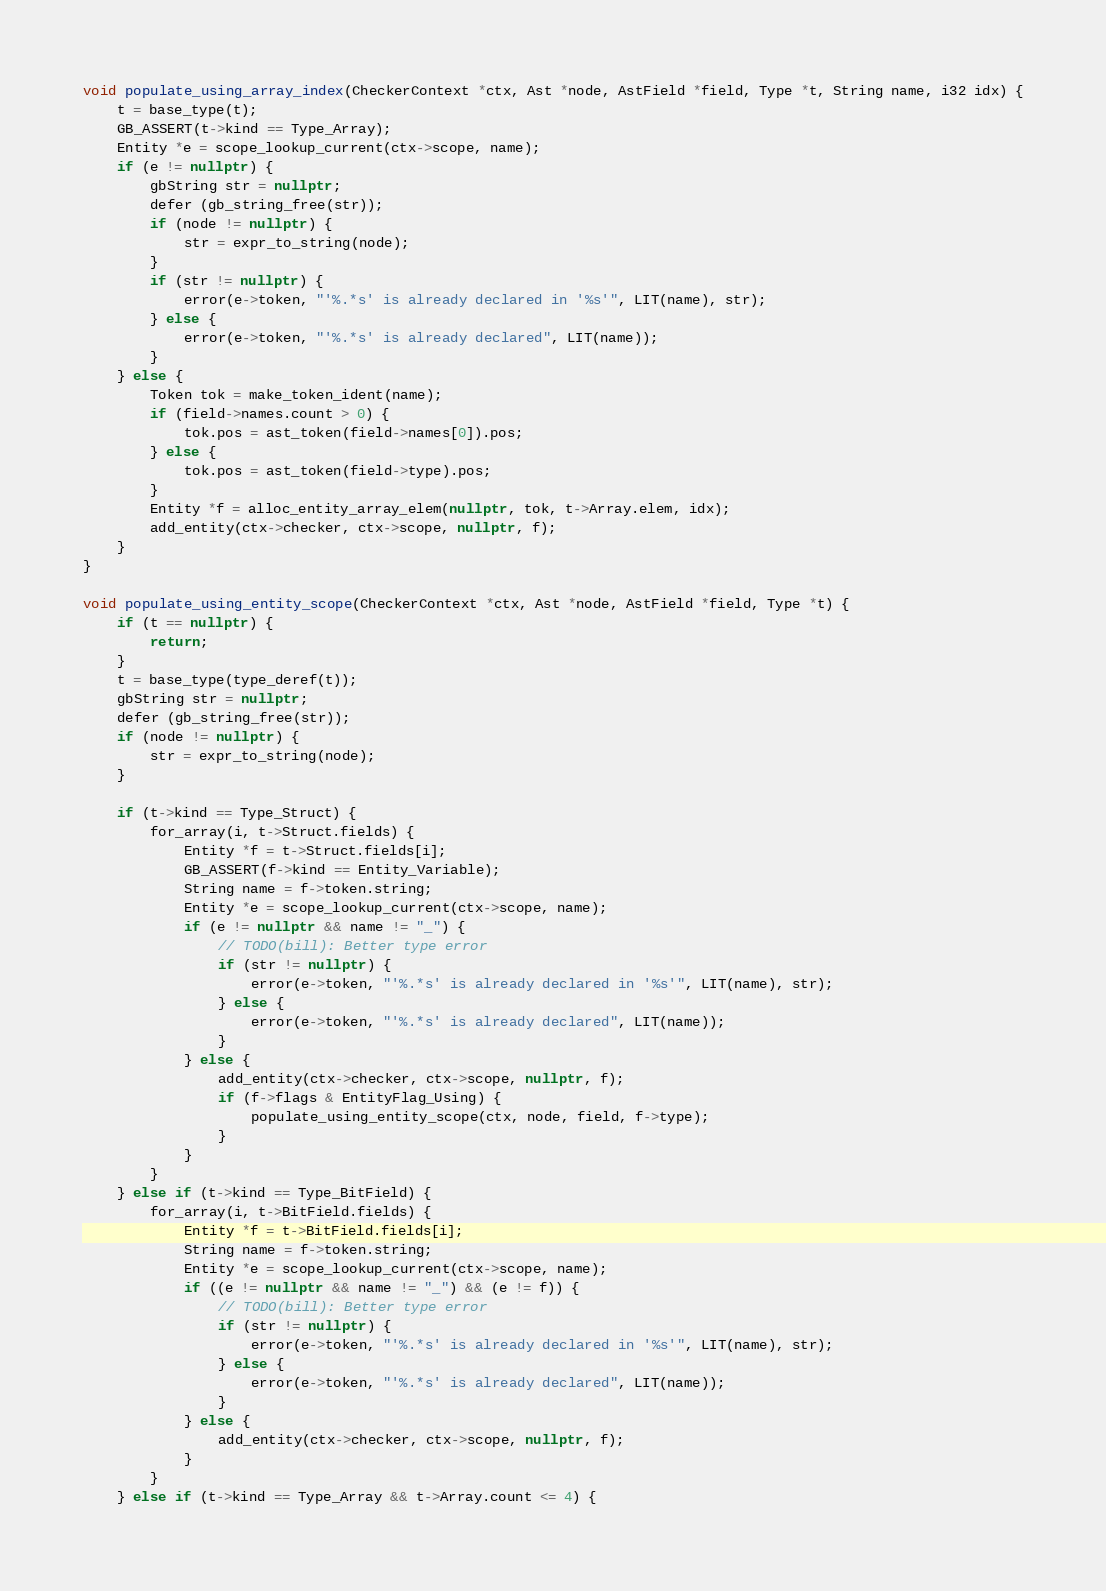Convert code to text. <code><loc_0><loc_0><loc_500><loc_500><_C++_>
void populate_using_array_index(CheckerContext *ctx, Ast *node, AstField *field, Type *t, String name, i32 idx) {
	t = base_type(t);
	GB_ASSERT(t->kind == Type_Array);
	Entity *e = scope_lookup_current(ctx->scope, name);
	if (e != nullptr) {
		gbString str = nullptr;
		defer (gb_string_free(str));
		if (node != nullptr) {
			str = expr_to_string(node);
		}
		if (str != nullptr) {
			error(e->token, "'%.*s' is already declared in '%s'", LIT(name), str);
		} else {
			error(e->token, "'%.*s' is already declared", LIT(name));
		}
	} else {
		Token tok = make_token_ident(name);
		if (field->names.count > 0) {
			tok.pos = ast_token(field->names[0]).pos;
		} else {
			tok.pos = ast_token(field->type).pos;
		}
		Entity *f = alloc_entity_array_elem(nullptr, tok, t->Array.elem, idx);
		add_entity(ctx->checker, ctx->scope, nullptr, f);
	}
}

void populate_using_entity_scope(CheckerContext *ctx, Ast *node, AstField *field, Type *t) {
	if (t == nullptr) {
		return;
	}
	t = base_type(type_deref(t));
	gbString str = nullptr;
	defer (gb_string_free(str));
	if (node != nullptr) {
		str = expr_to_string(node);
	}

	if (t->kind == Type_Struct) {
		for_array(i, t->Struct.fields) {
			Entity *f = t->Struct.fields[i];
			GB_ASSERT(f->kind == Entity_Variable);
			String name = f->token.string;
			Entity *e = scope_lookup_current(ctx->scope, name);
			if (e != nullptr && name != "_") {
				// TODO(bill): Better type error
				if (str != nullptr) {
					error(e->token, "'%.*s' is already declared in '%s'", LIT(name), str);
				} else {
					error(e->token, "'%.*s' is already declared", LIT(name));
				}
			} else {
				add_entity(ctx->checker, ctx->scope, nullptr, f);
				if (f->flags & EntityFlag_Using) {
					populate_using_entity_scope(ctx, node, field, f->type);
				}
			}
		}
	} else if (t->kind == Type_BitField) {
		for_array(i, t->BitField.fields) {
			Entity *f = t->BitField.fields[i];
			String name = f->token.string;
			Entity *e = scope_lookup_current(ctx->scope, name);
			if ((e != nullptr && name != "_") && (e != f)) {
				// TODO(bill): Better type error
				if (str != nullptr) {
					error(e->token, "'%.*s' is already declared in '%s'", LIT(name), str);
				} else {
					error(e->token, "'%.*s' is already declared", LIT(name));
				}
			} else {
				add_entity(ctx->checker, ctx->scope, nullptr, f);
			}
		}
	} else if (t->kind == Type_Array && t->Array.count <= 4) {</code> 